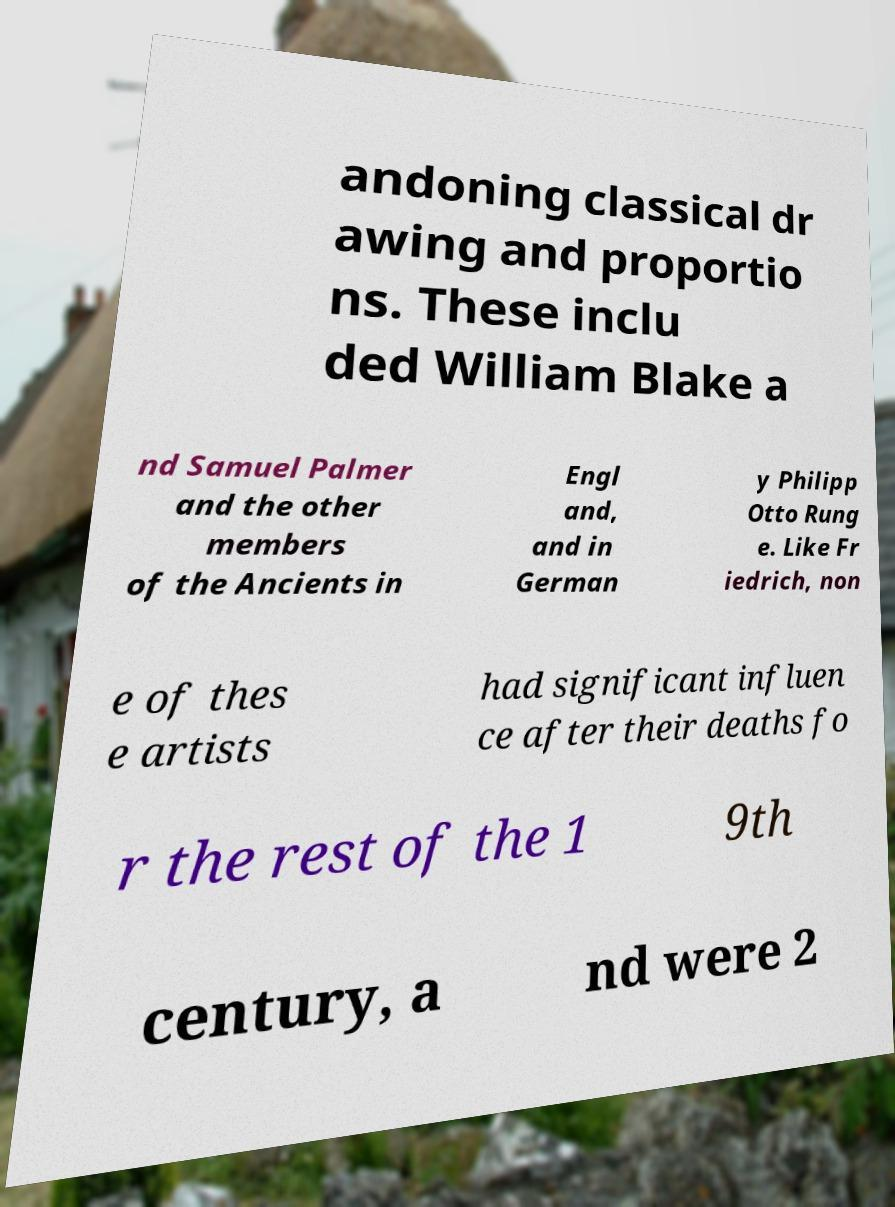There's text embedded in this image that I need extracted. Can you transcribe it verbatim? andoning classical dr awing and proportio ns. These inclu ded William Blake a nd Samuel Palmer and the other members of the Ancients in Engl and, and in German y Philipp Otto Rung e. Like Fr iedrich, non e of thes e artists had significant influen ce after their deaths fo r the rest of the 1 9th century, a nd were 2 